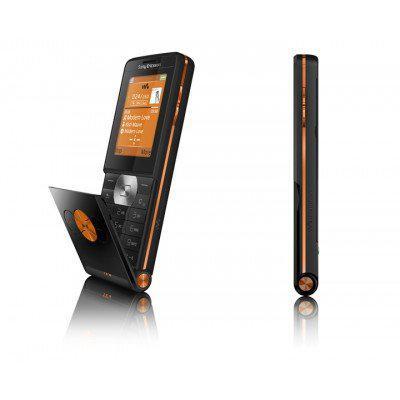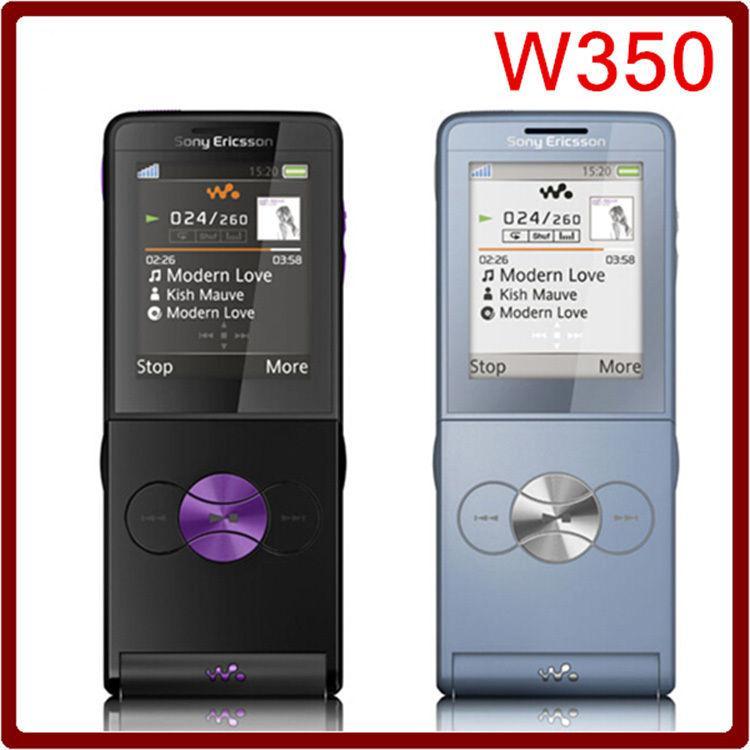The first image is the image on the left, the second image is the image on the right. Examine the images to the left and right. Is the description "One image shows exactly three phones, and the other image shows a single row containing at least four phones." accurate? Answer yes or no. No. The first image is the image on the left, the second image is the image on the right. For the images shown, is this caption "One of the pictures shows at least six phones side by side." true? Answer yes or no. No. 